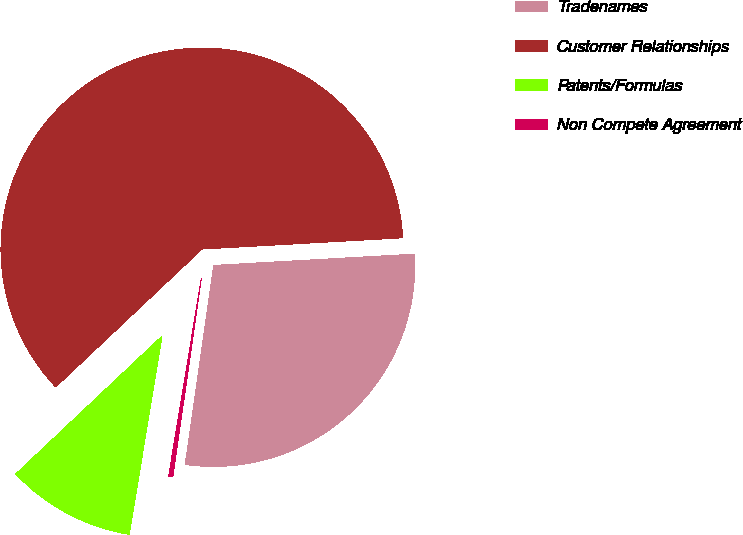Convert chart to OTSL. <chart><loc_0><loc_0><loc_500><loc_500><pie_chart><fcel>Tradenames<fcel>Customer Relationships<fcel>Patents/Formulas<fcel>Non Compete Agreement<nl><fcel>28.16%<fcel>61.14%<fcel>10.36%<fcel>0.34%<nl></chart> 